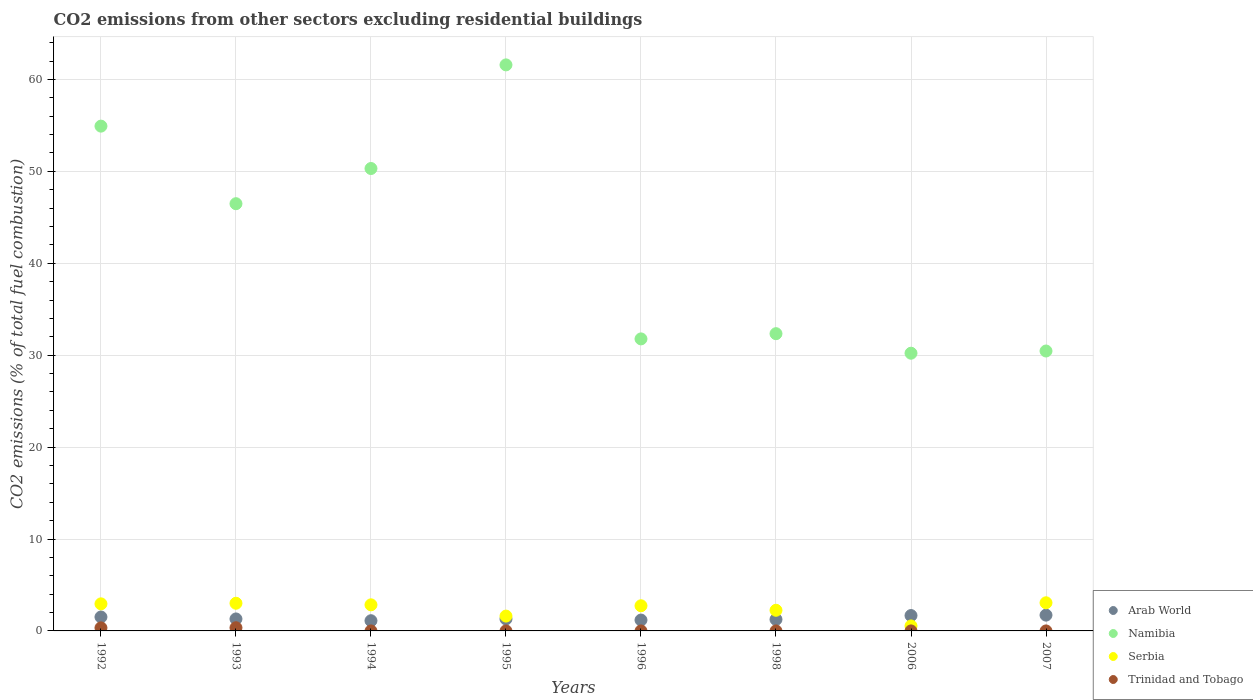How many different coloured dotlines are there?
Provide a short and direct response. 4. What is the total CO2 emitted in Trinidad and Tobago in 2007?
Keep it short and to the point. 4.75396951487204e-17. Across all years, what is the maximum total CO2 emitted in Trinidad and Tobago?
Your response must be concise. 0.35. Across all years, what is the minimum total CO2 emitted in Namibia?
Offer a very short reply. 30.21. What is the total total CO2 emitted in Trinidad and Tobago in the graph?
Your answer should be compact. 0.68. What is the difference between the total CO2 emitted in Serbia in 1995 and that in 2007?
Offer a very short reply. -1.45. What is the difference between the total CO2 emitted in Trinidad and Tobago in 1994 and the total CO2 emitted in Arab World in 1996?
Provide a short and direct response. -1.18. What is the average total CO2 emitted in Namibia per year?
Your response must be concise. 42.26. In the year 2006, what is the difference between the total CO2 emitted in Trinidad and Tobago and total CO2 emitted in Namibia?
Your answer should be compact. -30.21. In how many years, is the total CO2 emitted in Namibia greater than 48?
Your response must be concise. 3. What is the ratio of the total CO2 emitted in Namibia in 1992 to that in 1998?
Make the answer very short. 1.7. What is the difference between the highest and the second highest total CO2 emitted in Serbia?
Your answer should be very brief. 0.05. What is the difference between the highest and the lowest total CO2 emitted in Namibia?
Offer a very short reply. 31.37. In how many years, is the total CO2 emitted in Serbia greater than the average total CO2 emitted in Serbia taken over all years?
Keep it short and to the point. 5. Is the sum of the total CO2 emitted in Arab World in 1992 and 2007 greater than the maximum total CO2 emitted in Trinidad and Tobago across all years?
Your answer should be compact. Yes. Does the total CO2 emitted in Trinidad and Tobago monotonically increase over the years?
Provide a succinct answer. No. Is the total CO2 emitted in Trinidad and Tobago strictly greater than the total CO2 emitted in Arab World over the years?
Ensure brevity in your answer.  No. Is the total CO2 emitted in Arab World strictly less than the total CO2 emitted in Trinidad and Tobago over the years?
Provide a short and direct response. No. What is the difference between two consecutive major ticks on the Y-axis?
Your response must be concise. 10. Are the values on the major ticks of Y-axis written in scientific E-notation?
Your answer should be very brief. No. Does the graph contain any zero values?
Provide a short and direct response. Yes. How many legend labels are there?
Your answer should be compact. 4. How are the legend labels stacked?
Offer a terse response. Vertical. What is the title of the graph?
Provide a succinct answer. CO2 emissions from other sectors excluding residential buildings. Does "Mongolia" appear as one of the legend labels in the graph?
Provide a succinct answer. No. What is the label or title of the Y-axis?
Make the answer very short. CO2 emissions (% of total fuel combustion). What is the CO2 emissions (% of total fuel combustion) of Arab World in 1992?
Your response must be concise. 1.52. What is the CO2 emissions (% of total fuel combustion) of Namibia in 1992?
Make the answer very short. 54.92. What is the CO2 emissions (% of total fuel combustion) of Serbia in 1992?
Your response must be concise. 2.94. What is the CO2 emissions (% of total fuel combustion) in Trinidad and Tobago in 1992?
Your response must be concise. 0.33. What is the CO2 emissions (% of total fuel combustion) of Arab World in 1993?
Provide a succinct answer. 1.3. What is the CO2 emissions (% of total fuel combustion) of Namibia in 1993?
Ensure brevity in your answer.  46.48. What is the CO2 emissions (% of total fuel combustion) of Serbia in 1993?
Your answer should be compact. 3.01. What is the CO2 emissions (% of total fuel combustion) in Trinidad and Tobago in 1993?
Your answer should be compact. 0.35. What is the CO2 emissions (% of total fuel combustion) in Arab World in 1994?
Your answer should be compact. 1.11. What is the CO2 emissions (% of total fuel combustion) in Namibia in 1994?
Provide a succinct answer. 50.31. What is the CO2 emissions (% of total fuel combustion) of Serbia in 1994?
Your answer should be very brief. 2.84. What is the CO2 emissions (% of total fuel combustion) in Trinidad and Tobago in 1994?
Keep it short and to the point. 0. What is the CO2 emissions (% of total fuel combustion) in Arab World in 1995?
Make the answer very short. 1.3. What is the CO2 emissions (% of total fuel combustion) in Namibia in 1995?
Ensure brevity in your answer.  61.58. What is the CO2 emissions (% of total fuel combustion) of Serbia in 1995?
Offer a very short reply. 1.61. What is the CO2 emissions (% of total fuel combustion) in Arab World in 1996?
Provide a succinct answer. 1.18. What is the CO2 emissions (% of total fuel combustion) of Namibia in 1996?
Give a very brief answer. 31.77. What is the CO2 emissions (% of total fuel combustion) in Serbia in 1996?
Give a very brief answer. 2.74. What is the CO2 emissions (% of total fuel combustion) in Trinidad and Tobago in 1996?
Offer a terse response. 0. What is the CO2 emissions (% of total fuel combustion) in Arab World in 1998?
Keep it short and to the point. 1.25. What is the CO2 emissions (% of total fuel combustion) in Namibia in 1998?
Keep it short and to the point. 32.34. What is the CO2 emissions (% of total fuel combustion) in Serbia in 1998?
Your response must be concise. 2.25. What is the CO2 emissions (% of total fuel combustion) in Arab World in 2006?
Make the answer very short. 1.67. What is the CO2 emissions (% of total fuel combustion) in Namibia in 2006?
Ensure brevity in your answer.  30.21. What is the CO2 emissions (% of total fuel combustion) of Serbia in 2006?
Give a very brief answer. 0.54. What is the CO2 emissions (% of total fuel combustion) of Trinidad and Tobago in 2006?
Your answer should be very brief. 5.05750284541343e-17. What is the CO2 emissions (% of total fuel combustion) of Arab World in 2007?
Give a very brief answer. 1.72. What is the CO2 emissions (% of total fuel combustion) in Namibia in 2007?
Ensure brevity in your answer.  30.45. What is the CO2 emissions (% of total fuel combustion) of Serbia in 2007?
Make the answer very short. 3.06. What is the CO2 emissions (% of total fuel combustion) in Trinidad and Tobago in 2007?
Offer a very short reply. 4.75396951487204e-17. Across all years, what is the maximum CO2 emissions (% of total fuel combustion) of Arab World?
Offer a very short reply. 1.72. Across all years, what is the maximum CO2 emissions (% of total fuel combustion) of Namibia?
Offer a terse response. 61.58. Across all years, what is the maximum CO2 emissions (% of total fuel combustion) in Serbia?
Provide a short and direct response. 3.06. Across all years, what is the maximum CO2 emissions (% of total fuel combustion) in Trinidad and Tobago?
Your answer should be compact. 0.35. Across all years, what is the minimum CO2 emissions (% of total fuel combustion) in Arab World?
Make the answer very short. 1.11. Across all years, what is the minimum CO2 emissions (% of total fuel combustion) of Namibia?
Keep it short and to the point. 30.21. Across all years, what is the minimum CO2 emissions (% of total fuel combustion) in Serbia?
Ensure brevity in your answer.  0.54. What is the total CO2 emissions (% of total fuel combustion) in Arab World in the graph?
Your answer should be very brief. 11.05. What is the total CO2 emissions (% of total fuel combustion) in Namibia in the graph?
Your answer should be compact. 338.06. What is the total CO2 emissions (% of total fuel combustion) of Serbia in the graph?
Offer a terse response. 18.99. What is the total CO2 emissions (% of total fuel combustion) in Trinidad and Tobago in the graph?
Offer a very short reply. 0.68. What is the difference between the CO2 emissions (% of total fuel combustion) of Arab World in 1992 and that in 1993?
Give a very brief answer. 0.21. What is the difference between the CO2 emissions (% of total fuel combustion) of Namibia in 1992 and that in 1993?
Offer a very short reply. 8.44. What is the difference between the CO2 emissions (% of total fuel combustion) of Serbia in 1992 and that in 1993?
Offer a terse response. -0.07. What is the difference between the CO2 emissions (% of total fuel combustion) of Trinidad and Tobago in 1992 and that in 1993?
Your answer should be compact. -0.01. What is the difference between the CO2 emissions (% of total fuel combustion) of Arab World in 1992 and that in 1994?
Offer a very short reply. 0.41. What is the difference between the CO2 emissions (% of total fuel combustion) in Namibia in 1992 and that in 1994?
Provide a short and direct response. 4.61. What is the difference between the CO2 emissions (% of total fuel combustion) in Serbia in 1992 and that in 1994?
Your answer should be compact. 0.11. What is the difference between the CO2 emissions (% of total fuel combustion) of Arab World in 1992 and that in 1995?
Ensure brevity in your answer.  0.22. What is the difference between the CO2 emissions (% of total fuel combustion) in Namibia in 1992 and that in 1995?
Provide a short and direct response. -6.66. What is the difference between the CO2 emissions (% of total fuel combustion) of Serbia in 1992 and that in 1995?
Offer a terse response. 1.33. What is the difference between the CO2 emissions (% of total fuel combustion) in Arab World in 1992 and that in 1996?
Your response must be concise. 0.33. What is the difference between the CO2 emissions (% of total fuel combustion) of Namibia in 1992 and that in 1996?
Keep it short and to the point. 23.15. What is the difference between the CO2 emissions (% of total fuel combustion) in Serbia in 1992 and that in 1996?
Make the answer very short. 0.21. What is the difference between the CO2 emissions (% of total fuel combustion) in Arab World in 1992 and that in 1998?
Give a very brief answer. 0.27. What is the difference between the CO2 emissions (% of total fuel combustion) in Namibia in 1992 and that in 1998?
Provide a short and direct response. 22.58. What is the difference between the CO2 emissions (% of total fuel combustion) in Serbia in 1992 and that in 1998?
Offer a terse response. 0.7. What is the difference between the CO2 emissions (% of total fuel combustion) in Arab World in 1992 and that in 2006?
Your response must be concise. -0.16. What is the difference between the CO2 emissions (% of total fuel combustion) in Namibia in 1992 and that in 2006?
Your response must be concise. 24.71. What is the difference between the CO2 emissions (% of total fuel combustion) in Serbia in 1992 and that in 2006?
Your answer should be compact. 2.4. What is the difference between the CO2 emissions (% of total fuel combustion) of Trinidad and Tobago in 1992 and that in 2006?
Ensure brevity in your answer.  0.33. What is the difference between the CO2 emissions (% of total fuel combustion) in Arab World in 1992 and that in 2007?
Give a very brief answer. -0.2. What is the difference between the CO2 emissions (% of total fuel combustion) in Namibia in 1992 and that in 2007?
Your answer should be very brief. 24.47. What is the difference between the CO2 emissions (% of total fuel combustion) in Serbia in 1992 and that in 2007?
Provide a succinct answer. -0.12. What is the difference between the CO2 emissions (% of total fuel combustion) in Trinidad and Tobago in 1992 and that in 2007?
Keep it short and to the point. 0.33. What is the difference between the CO2 emissions (% of total fuel combustion) of Arab World in 1993 and that in 1994?
Ensure brevity in your answer.  0.19. What is the difference between the CO2 emissions (% of total fuel combustion) of Namibia in 1993 and that in 1994?
Keep it short and to the point. -3.83. What is the difference between the CO2 emissions (% of total fuel combustion) of Serbia in 1993 and that in 1994?
Give a very brief answer. 0.17. What is the difference between the CO2 emissions (% of total fuel combustion) of Arab World in 1993 and that in 1995?
Your answer should be very brief. 0. What is the difference between the CO2 emissions (% of total fuel combustion) of Namibia in 1993 and that in 1995?
Keep it short and to the point. -15.1. What is the difference between the CO2 emissions (% of total fuel combustion) in Serbia in 1993 and that in 1995?
Keep it short and to the point. 1.4. What is the difference between the CO2 emissions (% of total fuel combustion) of Arab World in 1993 and that in 1996?
Give a very brief answer. 0.12. What is the difference between the CO2 emissions (% of total fuel combustion) in Namibia in 1993 and that in 1996?
Your response must be concise. 14.71. What is the difference between the CO2 emissions (% of total fuel combustion) of Serbia in 1993 and that in 1996?
Ensure brevity in your answer.  0.27. What is the difference between the CO2 emissions (% of total fuel combustion) of Arab World in 1993 and that in 1998?
Provide a short and direct response. 0.06. What is the difference between the CO2 emissions (% of total fuel combustion) of Namibia in 1993 and that in 1998?
Ensure brevity in your answer.  14.14. What is the difference between the CO2 emissions (% of total fuel combustion) in Serbia in 1993 and that in 1998?
Your answer should be compact. 0.76. What is the difference between the CO2 emissions (% of total fuel combustion) of Arab World in 1993 and that in 2006?
Your response must be concise. -0.37. What is the difference between the CO2 emissions (% of total fuel combustion) of Namibia in 1993 and that in 2006?
Provide a succinct answer. 16.27. What is the difference between the CO2 emissions (% of total fuel combustion) in Serbia in 1993 and that in 2006?
Offer a very short reply. 2.47. What is the difference between the CO2 emissions (% of total fuel combustion) in Trinidad and Tobago in 1993 and that in 2006?
Give a very brief answer. 0.35. What is the difference between the CO2 emissions (% of total fuel combustion) in Arab World in 1993 and that in 2007?
Keep it short and to the point. -0.42. What is the difference between the CO2 emissions (% of total fuel combustion) in Namibia in 1993 and that in 2007?
Offer a terse response. 16.03. What is the difference between the CO2 emissions (% of total fuel combustion) in Serbia in 1993 and that in 2007?
Provide a short and direct response. -0.05. What is the difference between the CO2 emissions (% of total fuel combustion) of Trinidad and Tobago in 1993 and that in 2007?
Ensure brevity in your answer.  0.35. What is the difference between the CO2 emissions (% of total fuel combustion) in Arab World in 1994 and that in 1995?
Offer a terse response. -0.19. What is the difference between the CO2 emissions (% of total fuel combustion) of Namibia in 1994 and that in 1995?
Your response must be concise. -11.28. What is the difference between the CO2 emissions (% of total fuel combustion) in Serbia in 1994 and that in 1995?
Your answer should be compact. 1.22. What is the difference between the CO2 emissions (% of total fuel combustion) in Arab World in 1994 and that in 1996?
Keep it short and to the point. -0.07. What is the difference between the CO2 emissions (% of total fuel combustion) of Namibia in 1994 and that in 1996?
Offer a terse response. 18.54. What is the difference between the CO2 emissions (% of total fuel combustion) of Serbia in 1994 and that in 1996?
Ensure brevity in your answer.  0.1. What is the difference between the CO2 emissions (% of total fuel combustion) in Arab World in 1994 and that in 1998?
Ensure brevity in your answer.  -0.14. What is the difference between the CO2 emissions (% of total fuel combustion) of Namibia in 1994 and that in 1998?
Give a very brief answer. 17.97. What is the difference between the CO2 emissions (% of total fuel combustion) of Serbia in 1994 and that in 1998?
Give a very brief answer. 0.59. What is the difference between the CO2 emissions (% of total fuel combustion) of Arab World in 1994 and that in 2006?
Provide a short and direct response. -0.56. What is the difference between the CO2 emissions (% of total fuel combustion) in Namibia in 1994 and that in 2006?
Offer a terse response. 20.09. What is the difference between the CO2 emissions (% of total fuel combustion) in Serbia in 1994 and that in 2006?
Provide a short and direct response. 2.3. What is the difference between the CO2 emissions (% of total fuel combustion) of Arab World in 1994 and that in 2007?
Your answer should be very brief. -0.61. What is the difference between the CO2 emissions (% of total fuel combustion) in Namibia in 1994 and that in 2007?
Offer a very short reply. 19.85. What is the difference between the CO2 emissions (% of total fuel combustion) of Serbia in 1994 and that in 2007?
Your answer should be compact. -0.22. What is the difference between the CO2 emissions (% of total fuel combustion) in Arab World in 1995 and that in 1996?
Give a very brief answer. 0.12. What is the difference between the CO2 emissions (% of total fuel combustion) in Namibia in 1995 and that in 1996?
Give a very brief answer. 29.81. What is the difference between the CO2 emissions (% of total fuel combustion) of Serbia in 1995 and that in 1996?
Provide a short and direct response. -1.12. What is the difference between the CO2 emissions (% of total fuel combustion) in Arab World in 1995 and that in 1998?
Give a very brief answer. 0.05. What is the difference between the CO2 emissions (% of total fuel combustion) in Namibia in 1995 and that in 1998?
Your answer should be very brief. 29.24. What is the difference between the CO2 emissions (% of total fuel combustion) of Serbia in 1995 and that in 1998?
Your answer should be very brief. -0.63. What is the difference between the CO2 emissions (% of total fuel combustion) in Arab World in 1995 and that in 2006?
Offer a very short reply. -0.37. What is the difference between the CO2 emissions (% of total fuel combustion) of Namibia in 1995 and that in 2006?
Your response must be concise. 31.37. What is the difference between the CO2 emissions (% of total fuel combustion) of Serbia in 1995 and that in 2006?
Give a very brief answer. 1.07. What is the difference between the CO2 emissions (% of total fuel combustion) in Arab World in 1995 and that in 2007?
Provide a short and direct response. -0.42. What is the difference between the CO2 emissions (% of total fuel combustion) of Namibia in 1995 and that in 2007?
Offer a terse response. 31.13. What is the difference between the CO2 emissions (% of total fuel combustion) of Serbia in 1995 and that in 2007?
Make the answer very short. -1.45. What is the difference between the CO2 emissions (% of total fuel combustion) of Arab World in 1996 and that in 1998?
Offer a very short reply. -0.07. What is the difference between the CO2 emissions (% of total fuel combustion) of Namibia in 1996 and that in 1998?
Offer a very short reply. -0.57. What is the difference between the CO2 emissions (% of total fuel combustion) of Serbia in 1996 and that in 1998?
Offer a very short reply. 0.49. What is the difference between the CO2 emissions (% of total fuel combustion) in Arab World in 1996 and that in 2006?
Give a very brief answer. -0.49. What is the difference between the CO2 emissions (% of total fuel combustion) of Namibia in 1996 and that in 2006?
Offer a terse response. 1.56. What is the difference between the CO2 emissions (% of total fuel combustion) of Serbia in 1996 and that in 2006?
Offer a very short reply. 2.19. What is the difference between the CO2 emissions (% of total fuel combustion) in Arab World in 1996 and that in 2007?
Offer a very short reply. -0.54. What is the difference between the CO2 emissions (% of total fuel combustion) of Namibia in 1996 and that in 2007?
Your answer should be compact. 1.32. What is the difference between the CO2 emissions (% of total fuel combustion) in Serbia in 1996 and that in 2007?
Ensure brevity in your answer.  -0.33. What is the difference between the CO2 emissions (% of total fuel combustion) of Arab World in 1998 and that in 2006?
Keep it short and to the point. -0.42. What is the difference between the CO2 emissions (% of total fuel combustion) of Namibia in 1998 and that in 2006?
Offer a very short reply. 2.13. What is the difference between the CO2 emissions (% of total fuel combustion) in Serbia in 1998 and that in 2006?
Ensure brevity in your answer.  1.7. What is the difference between the CO2 emissions (% of total fuel combustion) in Arab World in 1998 and that in 2007?
Provide a short and direct response. -0.47. What is the difference between the CO2 emissions (% of total fuel combustion) of Namibia in 1998 and that in 2007?
Give a very brief answer. 1.89. What is the difference between the CO2 emissions (% of total fuel combustion) in Serbia in 1998 and that in 2007?
Offer a terse response. -0.82. What is the difference between the CO2 emissions (% of total fuel combustion) of Arab World in 2006 and that in 2007?
Keep it short and to the point. -0.05. What is the difference between the CO2 emissions (% of total fuel combustion) in Namibia in 2006 and that in 2007?
Keep it short and to the point. -0.24. What is the difference between the CO2 emissions (% of total fuel combustion) of Serbia in 2006 and that in 2007?
Your answer should be compact. -2.52. What is the difference between the CO2 emissions (% of total fuel combustion) in Trinidad and Tobago in 2006 and that in 2007?
Make the answer very short. 0. What is the difference between the CO2 emissions (% of total fuel combustion) of Arab World in 1992 and the CO2 emissions (% of total fuel combustion) of Namibia in 1993?
Ensure brevity in your answer.  -44.96. What is the difference between the CO2 emissions (% of total fuel combustion) of Arab World in 1992 and the CO2 emissions (% of total fuel combustion) of Serbia in 1993?
Provide a short and direct response. -1.5. What is the difference between the CO2 emissions (% of total fuel combustion) of Arab World in 1992 and the CO2 emissions (% of total fuel combustion) of Trinidad and Tobago in 1993?
Your answer should be very brief. 1.17. What is the difference between the CO2 emissions (% of total fuel combustion) in Namibia in 1992 and the CO2 emissions (% of total fuel combustion) in Serbia in 1993?
Keep it short and to the point. 51.91. What is the difference between the CO2 emissions (% of total fuel combustion) of Namibia in 1992 and the CO2 emissions (% of total fuel combustion) of Trinidad and Tobago in 1993?
Provide a short and direct response. 54.57. What is the difference between the CO2 emissions (% of total fuel combustion) of Serbia in 1992 and the CO2 emissions (% of total fuel combustion) of Trinidad and Tobago in 1993?
Give a very brief answer. 2.6. What is the difference between the CO2 emissions (% of total fuel combustion) in Arab World in 1992 and the CO2 emissions (% of total fuel combustion) in Namibia in 1994?
Your answer should be very brief. -48.79. What is the difference between the CO2 emissions (% of total fuel combustion) in Arab World in 1992 and the CO2 emissions (% of total fuel combustion) in Serbia in 1994?
Provide a succinct answer. -1.32. What is the difference between the CO2 emissions (% of total fuel combustion) of Namibia in 1992 and the CO2 emissions (% of total fuel combustion) of Serbia in 1994?
Make the answer very short. 52.08. What is the difference between the CO2 emissions (% of total fuel combustion) of Arab World in 1992 and the CO2 emissions (% of total fuel combustion) of Namibia in 1995?
Your response must be concise. -60.07. What is the difference between the CO2 emissions (% of total fuel combustion) of Arab World in 1992 and the CO2 emissions (% of total fuel combustion) of Serbia in 1995?
Keep it short and to the point. -0.1. What is the difference between the CO2 emissions (% of total fuel combustion) of Namibia in 1992 and the CO2 emissions (% of total fuel combustion) of Serbia in 1995?
Your answer should be compact. 53.3. What is the difference between the CO2 emissions (% of total fuel combustion) of Arab World in 1992 and the CO2 emissions (% of total fuel combustion) of Namibia in 1996?
Make the answer very short. -30.26. What is the difference between the CO2 emissions (% of total fuel combustion) of Arab World in 1992 and the CO2 emissions (% of total fuel combustion) of Serbia in 1996?
Offer a very short reply. -1.22. What is the difference between the CO2 emissions (% of total fuel combustion) of Namibia in 1992 and the CO2 emissions (% of total fuel combustion) of Serbia in 1996?
Give a very brief answer. 52.18. What is the difference between the CO2 emissions (% of total fuel combustion) of Arab World in 1992 and the CO2 emissions (% of total fuel combustion) of Namibia in 1998?
Your answer should be compact. -30.82. What is the difference between the CO2 emissions (% of total fuel combustion) in Arab World in 1992 and the CO2 emissions (% of total fuel combustion) in Serbia in 1998?
Make the answer very short. -0.73. What is the difference between the CO2 emissions (% of total fuel combustion) in Namibia in 1992 and the CO2 emissions (% of total fuel combustion) in Serbia in 1998?
Keep it short and to the point. 52.67. What is the difference between the CO2 emissions (% of total fuel combustion) in Arab World in 1992 and the CO2 emissions (% of total fuel combustion) in Namibia in 2006?
Provide a short and direct response. -28.7. What is the difference between the CO2 emissions (% of total fuel combustion) in Arab World in 1992 and the CO2 emissions (% of total fuel combustion) in Serbia in 2006?
Provide a short and direct response. 0.97. What is the difference between the CO2 emissions (% of total fuel combustion) in Arab World in 1992 and the CO2 emissions (% of total fuel combustion) in Trinidad and Tobago in 2006?
Ensure brevity in your answer.  1.52. What is the difference between the CO2 emissions (% of total fuel combustion) of Namibia in 1992 and the CO2 emissions (% of total fuel combustion) of Serbia in 2006?
Keep it short and to the point. 54.38. What is the difference between the CO2 emissions (% of total fuel combustion) of Namibia in 1992 and the CO2 emissions (% of total fuel combustion) of Trinidad and Tobago in 2006?
Offer a very short reply. 54.92. What is the difference between the CO2 emissions (% of total fuel combustion) in Serbia in 1992 and the CO2 emissions (% of total fuel combustion) in Trinidad and Tobago in 2006?
Provide a short and direct response. 2.94. What is the difference between the CO2 emissions (% of total fuel combustion) of Arab World in 1992 and the CO2 emissions (% of total fuel combustion) of Namibia in 2007?
Ensure brevity in your answer.  -28.94. What is the difference between the CO2 emissions (% of total fuel combustion) in Arab World in 1992 and the CO2 emissions (% of total fuel combustion) in Serbia in 2007?
Make the answer very short. -1.55. What is the difference between the CO2 emissions (% of total fuel combustion) in Arab World in 1992 and the CO2 emissions (% of total fuel combustion) in Trinidad and Tobago in 2007?
Make the answer very short. 1.52. What is the difference between the CO2 emissions (% of total fuel combustion) in Namibia in 1992 and the CO2 emissions (% of total fuel combustion) in Serbia in 2007?
Your response must be concise. 51.86. What is the difference between the CO2 emissions (% of total fuel combustion) in Namibia in 1992 and the CO2 emissions (% of total fuel combustion) in Trinidad and Tobago in 2007?
Provide a succinct answer. 54.92. What is the difference between the CO2 emissions (% of total fuel combustion) in Serbia in 1992 and the CO2 emissions (% of total fuel combustion) in Trinidad and Tobago in 2007?
Give a very brief answer. 2.94. What is the difference between the CO2 emissions (% of total fuel combustion) of Arab World in 1993 and the CO2 emissions (% of total fuel combustion) of Namibia in 1994?
Keep it short and to the point. -49. What is the difference between the CO2 emissions (% of total fuel combustion) of Arab World in 1993 and the CO2 emissions (% of total fuel combustion) of Serbia in 1994?
Provide a short and direct response. -1.53. What is the difference between the CO2 emissions (% of total fuel combustion) of Namibia in 1993 and the CO2 emissions (% of total fuel combustion) of Serbia in 1994?
Keep it short and to the point. 43.64. What is the difference between the CO2 emissions (% of total fuel combustion) of Arab World in 1993 and the CO2 emissions (% of total fuel combustion) of Namibia in 1995?
Your answer should be compact. -60.28. What is the difference between the CO2 emissions (% of total fuel combustion) in Arab World in 1993 and the CO2 emissions (% of total fuel combustion) in Serbia in 1995?
Ensure brevity in your answer.  -0.31. What is the difference between the CO2 emissions (% of total fuel combustion) in Namibia in 1993 and the CO2 emissions (% of total fuel combustion) in Serbia in 1995?
Your answer should be compact. 44.86. What is the difference between the CO2 emissions (% of total fuel combustion) of Arab World in 1993 and the CO2 emissions (% of total fuel combustion) of Namibia in 1996?
Your answer should be compact. -30.47. What is the difference between the CO2 emissions (% of total fuel combustion) in Arab World in 1993 and the CO2 emissions (% of total fuel combustion) in Serbia in 1996?
Give a very brief answer. -1.43. What is the difference between the CO2 emissions (% of total fuel combustion) of Namibia in 1993 and the CO2 emissions (% of total fuel combustion) of Serbia in 1996?
Make the answer very short. 43.74. What is the difference between the CO2 emissions (% of total fuel combustion) of Arab World in 1993 and the CO2 emissions (% of total fuel combustion) of Namibia in 1998?
Offer a terse response. -31.03. What is the difference between the CO2 emissions (% of total fuel combustion) in Arab World in 1993 and the CO2 emissions (% of total fuel combustion) in Serbia in 1998?
Keep it short and to the point. -0.94. What is the difference between the CO2 emissions (% of total fuel combustion) of Namibia in 1993 and the CO2 emissions (% of total fuel combustion) of Serbia in 1998?
Ensure brevity in your answer.  44.23. What is the difference between the CO2 emissions (% of total fuel combustion) of Arab World in 1993 and the CO2 emissions (% of total fuel combustion) of Namibia in 2006?
Provide a succinct answer. -28.91. What is the difference between the CO2 emissions (% of total fuel combustion) of Arab World in 1993 and the CO2 emissions (% of total fuel combustion) of Serbia in 2006?
Keep it short and to the point. 0.76. What is the difference between the CO2 emissions (% of total fuel combustion) in Arab World in 1993 and the CO2 emissions (% of total fuel combustion) in Trinidad and Tobago in 2006?
Keep it short and to the point. 1.3. What is the difference between the CO2 emissions (% of total fuel combustion) of Namibia in 1993 and the CO2 emissions (% of total fuel combustion) of Serbia in 2006?
Ensure brevity in your answer.  45.94. What is the difference between the CO2 emissions (% of total fuel combustion) of Namibia in 1993 and the CO2 emissions (% of total fuel combustion) of Trinidad and Tobago in 2006?
Give a very brief answer. 46.48. What is the difference between the CO2 emissions (% of total fuel combustion) of Serbia in 1993 and the CO2 emissions (% of total fuel combustion) of Trinidad and Tobago in 2006?
Your answer should be very brief. 3.01. What is the difference between the CO2 emissions (% of total fuel combustion) of Arab World in 1993 and the CO2 emissions (% of total fuel combustion) of Namibia in 2007?
Provide a succinct answer. -29.15. What is the difference between the CO2 emissions (% of total fuel combustion) in Arab World in 1993 and the CO2 emissions (% of total fuel combustion) in Serbia in 2007?
Your response must be concise. -1.76. What is the difference between the CO2 emissions (% of total fuel combustion) of Arab World in 1993 and the CO2 emissions (% of total fuel combustion) of Trinidad and Tobago in 2007?
Keep it short and to the point. 1.3. What is the difference between the CO2 emissions (% of total fuel combustion) in Namibia in 1993 and the CO2 emissions (% of total fuel combustion) in Serbia in 2007?
Provide a short and direct response. 43.42. What is the difference between the CO2 emissions (% of total fuel combustion) of Namibia in 1993 and the CO2 emissions (% of total fuel combustion) of Trinidad and Tobago in 2007?
Make the answer very short. 46.48. What is the difference between the CO2 emissions (% of total fuel combustion) of Serbia in 1993 and the CO2 emissions (% of total fuel combustion) of Trinidad and Tobago in 2007?
Your answer should be compact. 3.01. What is the difference between the CO2 emissions (% of total fuel combustion) of Arab World in 1994 and the CO2 emissions (% of total fuel combustion) of Namibia in 1995?
Give a very brief answer. -60.47. What is the difference between the CO2 emissions (% of total fuel combustion) of Arab World in 1994 and the CO2 emissions (% of total fuel combustion) of Serbia in 1995?
Make the answer very short. -0.5. What is the difference between the CO2 emissions (% of total fuel combustion) of Namibia in 1994 and the CO2 emissions (% of total fuel combustion) of Serbia in 1995?
Make the answer very short. 48.69. What is the difference between the CO2 emissions (% of total fuel combustion) in Arab World in 1994 and the CO2 emissions (% of total fuel combustion) in Namibia in 1996?
Ensure brevity in your answer.  -30.66. What is the difference between the CO2 emissions (% of total fuel combustion) of Arab World in 1994 and the CO2 emissions (% of total fuel combustion) of Serbia in 1996?
Give a very brief answer. -1.63. What is the difference between the CO2 emissions (% of total fuel combustion) of Namibia in 1994 and the CO2 emissions (% of total fuel combustion) of Serbia in 1996?
Your answer should be very brief. 47.57. What is the difference between the CO2 emissions (% of total fuel combustion) of Arab World in 1994 and the CO2 emissions (% of total fuel combustion) of Namibia in 1998?
Offer a terse response. -31.23. What is the difference between the CO2 emissions (% of total fuel combustion) of Arab World in 1994 and the CO2 emissions (% of total fuel combustion) of Serbia in 1998?
Provide a short and direct response. -1.14. What is the difference between the CO2 emissions (% of total fuel combustion) in Namibia in 1994 and the CO2 emissions (% of total fuel combustion) in Serbia in 1998?
Offer a very short reply. 48.06. What is the difference between the CO2 emissions (% of total fuel combustion) in Arab World in 1994 and the CO2 emissions (% of total fuel combustion) in Namibia in 2006?
Provide a short and direct response. -29.1. What is the difference between the CO2 emissions (% of total fuel combustion) of Arab World in 1994 and the CO2 emissions (% of total fuel combustion) of Serbia in 2006?
Offer a terse response. 0.57. What is the difference between the CO2 emissions (% of total fuel combustion) of Arab World in 1994 and the CO2 emissions (% of total fuel combustion) of Trinidad and Tobago in 2006?
Your answer should be very brief. 1.11. What is the difference between the CO2 emissions (% of total fuel combustion) in Namibia in 1994 and the CO2 emissions (% of total fuel combustion) in Serbia in 2006?
Give a very brief answer. 49.76. What is the difference between the CO2 emissions (% of total fuel combustion) in Namibia in 1994 and the CO2 emissions (% of total fuel combustion) in Trinidad and Tobago in 2006?
Your answer should be very brief. 50.31. What is the difference between the CO2 emissions (% of total fuel combustion) of Serbia in 1994 and the CO2 emissions (% of total fuel combustion) of Trinidad and Tobago in 2006?
Your answer should be compact. 2.84. What is the difference between the CO2 emissions (% of total fuel combustion) in Arab World in 1994 and the CO2 emissions (% of total fuel combustion) in Namibia in 2007?
Make the answer very short. -29.34. What is the difference between the CO2 emissions (% of total fuel combustion) in Arab World in 1994 and the CO2 emissions (% of total fuel combustion) in Serbia in 2007?
Keep it short and to the point. -1.95. What is the difference between the CO2 emissions (% of total fuel combustion) in Arab World in 1994 and the CO2 emissions (% of total fuel combustion) in Trinidad and Tobago in 2007?
Make the answer very short. 1.11. What is the difference between the CO2 emissions (% of total fuel combustion) of Namibia in 1994 and the CO2 emissions (% of total fuel combustion) of Serbia in 2007?
Your response must be concise. 47.25. What is the difference between the CO2 emissions (% of total fuel combustion) in Namibia in 1994 and the CO2 emissions (% of total fuel combustion) in Trinidad and Tobago in 2007?
Ensure brevity in your answer.  50.31. What is the difference between the CO2 emissions (% of total fuel combustion) of Serbia in 1994 and the CO2 emissions (% of total fuel combustion) of Trinidad and Tobago in 2007?
Ensure brevity in your answer.  2.84. What is the difference between the CO2 emissions (% of total fuel combustion) in Arab World in 1995 and the CO2 emissions (% of total fuel combustion) in Namibia in 1996?
Offer a very short reply. -30.47. What is the difference between the CO2 emissions (% of total fuel combustion) of Arab World in 1995 and the CO2 emissions (% of total fuel combustion) of Serbia in 1996?
Give a very brief answer. -1.44. What is the difference between the CO2 emissions (% of total fuel combustion) in Namibia in 1995 and the CO2 emissions (% of total fuel combustion) in Serbia in 1996?
Give a very brief answer. 58.85. What is the difference between the CO2 emissions (% of total fuel combustion) in Arab World in 1995 and the CO2 emissions (% of total fuel combustion) in Namibia in 1998?
Your response must be concise. -31.04. What is the difference between the CO2 emissions (% of total fuel combustion) of Arab World in 1995 and the CO2 emissions (% of total fuel combustion) of Serbia in 1998?
Offer a terse response. -0.95. What is the difference between the CO2 emissions (% of total fuel combustion) in Namibia in 1995 and the CO2 emissions (% of total fuel combustion) in Serbia in 1998?
Your response must be concise. 59.34. What is the difference between the CO2 emissions (% of total fuel combustion) of Arab World in 1995 and the CO2 emissions (% of total fuel combustion) of Namibia in 2006?
Make the answer very short. -28.91. What is the difference between the CO2 emissions (% of total fuel combustion) of Arab World in 1995 and the CO2 emissions (% of total fuel combustion) of Serbia in 2006?
Make the answer very short. 0.76. What is the difference between the CO2 emissions (% of total fuel combustion) in Arab World in 1995 and the CO2 emissions (% of total fuel combustion) in Trinidad and Tobago in 2006?
Give a very brief answer. 1.3. What is the difference between the CO2 emissions (% of total fuel combustion) of Namibia in 1995 and the CO2 emissions (% of total fuel combustion) of Serbia in 2006?
Offer a terse response. 61.04. What is the difference between the CO2 emissions (% of total fuel combustion) of Namibia in 1995 and the CO2 emissions (% of total fuel combustion) of Trinidad and Tobago in 2006?
Your answer should be compact. 61.58. What is the difference between the CO2 emissions (% of total fuel combustion) in Serbia in 1995 and the CO2 emissions (% of total fuel combustion) in Trinidad and Tobago in 2006?
Make the answer very short. 1.61. What is the difference between the CO2 emissions (% of total fuel combustion) of Arab World in 1995 and the CO2 emissions (% of total fuel combustion) of Namibia in 2007?
Provide a short and direct response. -29.15. What is the difference between the CO2 emissions (% of total fuel combustion) in Arab World in 1995 and the CO2 emissions (% of total fuel combustion) in Serbia in 2007?
Offer a very short reply. -1.76. What is the difference between the CO2 emissions (% of total fuel combustion) of Arab World in 1995 and the CO2 emissions (% of total fuel combustion) of Trinidad and Tobago in 2007?
Your response must be concise. 1.3. What is the difference between the CO2 emissions (% of total fuel combustion) in Namibia in 1995 and the CO2 emissions (% of total fuel combustion) in Serbia in 2007?
Provide a succinct answer. 58.52. What is the difference between the CO2 emissions (% of total fuel combustion) of Namibia in 1995 and the CO2 emissions (% of total fuel combustion) of Trinidad and Tobago in 2007?
Provide a succinct answer. 61.58. What is the difference between the CO2 emissions (% of total fuel combustion) in Serbia in 1995 and the CO2 emissions (% of total fuel combustion) in Trinidad and Tobago in 2007?
Offer a terse response. 1.61. What is the difference between the CO2 emissions (% of total fuel combustion) in Arab World in 1996 and the CO2 emissions (% of total fuel combustion) in Namibia in 1998?
Ensure brevity in your answer.  -31.16. What is the difference between the CO2 emissions (% of total fuel combustion) in Arab World in 1996 and the CO2 emissions (% of total fuel combustion) in Serbia in 1998?
Provide a short and direct response. -1.06. What is the difference between the CO2 emissions (% of total fuel combustion) in Namibia in 1996 and the CO2 emissions (% of total fuel combustion) in Serbia in 1998?
Make the answer very short. 29.53. What is the difference between the CO2 emissions (% of total fuel combustion) of Arab World in 1996 and the CO2 emissions (% of total fuel combustion) of Namibia in 2006?
Provide a short and direct response. -29.03. What is the difference between the CO2 emissions (% of total fuel combustion) in Arab World in 1996 and the CO2 emissions (% of total fuel combustion) in Serbia in 2006?
Your response must be concise. 0.64. What is the difference between the CO2 emissions (% of total fuel combustion) in Arab World in 1996 and the CO2 emissions (% of total fuel combustion) in Trinidad and Tobago in 2006?
Keep it short and to the point. 1.18. What is the difference between the CO2 emissions (% of total fuel combustion) of Namibia in 1996 and the CO2 emissions (% of total fuel combustion) of Serbia in 2006?
Offer a very short reply. 31.23. What is the difference between the CO2 emissions (% of total fuel combustion) in Namibia in 1996 and the CO2 emissions (% of total fuel combustion) in Trinidad and Tobago in 2006?
Offer a very short reply. 31.77. What is the difference between the CO2 emissions (% of total fuel combustion) of Serbia in 1996 and the CO2 emissions (% of total fuel combustion) of Trinidad and Tobago in 2006?
Make the answer very short. 2.74. What is the difference between the CO2 emissions (% of total fuel combustion) of Arab World in 1996 and the CO2 emissions (% of total fuel combustion) of Namibia in 2007?
Keep it short and to the point. -29.27. What is the difference between the CO2 emissions (% of total fuel combustion) in Arab World in 1996 and the CO2 emissions (% of total fuel combustion) in Serbia in 2007?
Your answer should be compact. -1.88. What is the difference between the CO2 emissions (% of total fuel combustion) of Arab World in 1996 and the CO2 emissions (% of total fuel combustion) of Trinidad and Tobago in 2007?
Make the answer very short. 1.18. What is the difference between the CO2 emissions (% of total fuel combustion) in Namibia in 1996 and the CO2 emissions (% of total fuel combustion) in Serbia in 2007?
Give a very brief answer. 28.71. What is the difference between the CO2 emissions (% of total fuel combustion) in Namibia in 1996 and the CO2 emissions (% of total fuel combustion) in Trinidad and Tobago in 2007?
Ensure brevity in your answer.  31.77. What is the difference between the CO2 emissions (% of total fuel combustion) in Serbia in 1996 and the CO2 emissions (% of total fuel combustion) in Trinidad and Tobago in 2007?
Your answer should be compact. 2.74. What is the difference between the CO2 emissions (% of total fuel combustion) of Arab World in 1998 and the CO2 emissions (% of total fuel combustion) of Namibia in 2006?
Make the answer very short. -28.96. What is the difference between the CO2 emissions (% of total fuel combustion) in Arab World in 1998 and the CO2 emissions (% of total fuel combustion) in Serbia in 2006?
Offer a terse response. 0.71. What is the difference between the CO2 emissions (% of total fuel combustion) in Arab World in 1998 and the CO2 emissions (% of total fuel combustion) in Trinidad and Tobago in 2006?
Provide a short and direct response. 1.25. What is the difference between the CO2 emissions (% of total fuel combustion) of Namibia in 1998 and the CO2 emissions (% of total fuel combustion) of Serbia in 2006?
Keep it short and to the point. 31.8. What is the difference between the CO2 emissions (% of total fuel combustion) of Namibia in 1998 and the CO2 emissions (% of total fuel combustion) of Trinidad and Tobago in 2006?
Make the answer very short. 32.34. What is the difference between the CO2 emissions (% of total fuel combustion) of Serbia in 1998 and the CO2 emissions (% of total fuel combustion) of Trinidad and Tobago in 2006?
Provide a succinct answer. 2.25. What is the difference between the CO2 emissions (% of total fuel combustion) in Arab World in 1998 and the CO2 emissions (% of total fuel combustion) in Namibia in 2007?
Your response must be concise. -29.2. What is the difference between the CO2 emissions (% of total fuel combustion) of Arab World in 1998 and the CO2 emissions (% of total fuel combustion) of Serbia in 2007?
Keep it short and to the point. -1.81. What is the difference between the CO2 emissions (% of total fuel combustion) of Arab World in 1998 and the CO2 emissions (% of total fuel combustion) of Trinidad and Tobago in 2007?
Your response must be concise. 1.25. What is the difference between the CO2 emissions (% of total fuel combustion) in Namibia in 1998 and the CO2 emissions (% of total fuel combustion) in Serbia in 2007?
Keep it short and to the point. 29.28. What is the difference between the CO2 emissions (% of total fuel combustion) in Namibia in 1998 and the CO2 emissions (% of total fuel combustion) in Trinidad and Tobago in 2007?
Your answer should be very brief. 32.34. What is the difference between the CO2 emissions (% of total fuel combustion) of Serbia in 1998 and the CO2 emissions (% of total fuel combustion) of Trinidad and Tobago in 2007?
Provide a short and direct response. 2.25. What is the difference between the CO2 emissions (% of total fuel combustion) in Arab World in 2006 and the CO2 emissions (% of total fuel combustion) in Namibia in 2007?
Provide a succinct answer. -28.78. What is the difference between the CO2 emissions (% of total fuel combustion) in Arab World in 2006 and the CO2 emissions (% of total fuel combustion) in Serbia in 2007?
Make the answer very short. -1.39. What is the difference between the CO2 emissions (% of total fuel combustion) of Arab World in 2006 and the CO2 emissions (% of total fuel combustion) of Trinidad and Tobago in 2007?
Offer a terse response. 1.67. What is the difference between the CO2 emissions (% of total fuel combustion) in Namibia in 2006 and the CO2 emissions (% of total fuel combustion) in Serbia in 2007?
Your response must be concise. 27.15. What is the difference between the CO2 emissions (% of total fuel combustion) of Namibia in 2006 and the CO2 emissions (% of total fuel combustion) of Trinidad and Tobago in 2007?
Your answer should be compact. 30.21. What is the difference between the CO2 emissions (% of total fuel combustion) in Serbia in 2006 and the CO2 emissions (% of total fuel combustion) in Trinidad and Tobago in 2007?
Keep it short and to the point. 0.54. What is the average CO2 emissions (% of total fuel combustion) of Arab World per year?
Give a very brief answer. 1.38. What is the average CO2 emissions (% of total fuel combustion) in Namibia per year?
Give a very brief answer. 42.26. What is the average CO2 emissions (% of total fuel combustion) in Serbia per year?
Give a very brief answer. 2.37. What is the average CO2 emissions (% of total fuel combustion) in Trinidad and Tobago per year?
Your response must be concise. 0.09. In the year 1992, what is the difference between the CO2 emissions (% of total fuel combustion) of Arab World and CO2 emissions (% of total fuel combustion) of Namibia?
Provide a short and direct response. -53.4. In the year 1992, what is the difference between the CO2 emissions (% of total fuel combustion) in Arab World and CO2 emissions (% of total fuel combustion) in Serbia?
Keep it short and to the point. -1.43. In the year 1992, what is the difference between the CO2 emissions (% of total fuel combustion) in Arab World and CO2 emissions (% of total fuel combustion) in Trinidad and Tobago?
Your answer should be compact. 1.18. In the year 1992, what is the difference between the CO2 emissions (% of total fuel combustion) of Namibia and CO2 emissions (% of total fuel combustion) of Serbia?
Your answer should be very brief. 51.97. In the year 1992, what is the difference between the CO2 emissions (% of total fuel combustion) in Namibia and CO2 emissions (% of total fuel combustion) in Trinidad and Tobago?
Offer a very short reply. 54.58. In the year 1992, what is the difference between the CO2 emissions (% of total fuel combustion) of Serbia and CO2 emissions (% of total fuel combustion) of Trinidad and Tobago?
Offer a terse response. 2.61. In the year 1993, what is the difference between the CO2 emissions (% of total fuel combustion) of Arab World and CO2 emissions (% of total fuel combustion) of Namibia?
Your answer should be very brief. -45.17. In the year 1993, what is the difference between the CO2 emissions (% of total fuel combustion) in Arab World and CO2 emissions (% of total fuel combustion) in Serbia?
Your answer should be very brief. -1.71. In the year 1993, what is the difference between the CO2 emissions (% of total fuel combustion) of Arab World and CO2 emissions (% of total fuel combustion) of Trinidad and Tobago?
Your answer should be compact. 0.96. In the year 1993, what is the difference between the CO2 emissions (% of total fuel combustion) of Namibia and CO2 emissions (% of total fuel combustion) of Serbia?
Provide a short and direct response. 43.47. In the year 1993, what is the difference between the CO2 emissions (% of total fuel combustion) of Namibia and CO2 emissions (% of total fuel combustion) of Trinidad and Tobago?
Offer a terse response. 46.13. In the year 1993, what is the difference between the CO2 emissions (% of total fuel combustion) in Serbia and CO2 emissions (% of total fuel combustion) in Trinidad and Tobago?
Your answer should be compact. 2.66. In the year 1994, what is the difference between the CO2 emissions (% of total fuel combustion) of Arab World and CO2 emissions (% of total fuel combustion) of Namibia?
Your response must be concise. -49.2. In the year 1994, what is the difference between the CO2 emissions (% of total fuel combustion) of Arab World and CO2 emissions (% of total fuel combustion) of Serbia?
Keep it short and to the point. -1.73. In the year 1994, what is the difference between the CO2 emissions (% of total fuel combustion) in Namibia and CO2 emissions (% of total fuel combustion) in Serbia?
Provide a succinct answer. 47.47. In the year 1995, what is the difference between the CO2 emissions (% of total fuel combustion) of Arab World and CO2 emissions (% of total fuel combustion) of Namibia?
Offer a terse response. -60.28. In the year 1995, what is the difference between the CO2 emissions (% of total fuel combustion) of Arab World and CO2 emissions (% of total fuel combustion) of Serbia?
Offer a very short reply. -0.31. In the year 1995, what is the difference between the CO2 emissions (% of total fuel combustion) in Namibia and CO2 emissions (% of total fuel combustion) in Serbia?
Your answer should be compact. 59.97. In the year 1996, what is the difference between the CO2 emissions (% of total fuel combustion) in Arab World and CO2 emissions (% of total fuel combustion) in Namibia?
Your answer should be compact. -30.59. In the year 1996, what is the difference between the CO2 emissions (% of total fuel combustion) in Arab World and CO2 emissions (% of total fuel combustion) in Serbia?
Keep it short and to the point. -1.55. In the year 1996, what is the difference between the CO2 emissions (% of total fuel combustion) of Namibia and CO2 emissions (% of total fuel combustion) of Serbia?
Provide a succinct answer. 29.03. In the year 1998, what is the difference between the CO2 emissions (% of total fuel combustion) of Arab World and CO2 emissions (% of total fuel combustion) of Namibia?
Ensure brevity in your answer.  -31.09. In the year 1998, what is the difference between the CO2 emissions (% of total fuel combustion) of Arab World and CO2 emissions (% of total fuel combustion) of Serbia?
Ensure brevity in your answer.  -1. In the year 1998, what is the difference between the CO2 emissions (% of total fuel combustion) in Namibia and CO2 emissions (% of total fuel combustion) in Serbia?
Make the answer very short. 30.09. In the year 2006, what is the difference between the CO2 emissions (% of total fuel combustion) in Arab World and CO2 emissions (% of total fuel combustion) in Namibia?
Offer a terse response. -28.54. In the year 2006, what is the difference between the CO2 emissions (% of total fuel combustion) of Arab World and CO2 emissions (% of total fuel combustion) of Serbia?
Provide a short and direct response. 1.13. In the year 2006, what is the difference between the CO2 emissions (% of total fuel combustion) in Arab World and CO2 emissions (% of total fuel combustion) in Trinidad and Tobago?
Your answer should be compact. 1.67. In the year 2006, what is the difference between the CO2 emissions (% of total fuel combustion) in Namibia and CO2 emissions (% of total fuel combustion) in Serbia?
Keep it short and to the point. 29.67. In the year 2006, what is the difference between the CO2 emissions (% of total fuel combustion) in Namibia and CO2 emissions (% of total fuel combustion) in Trinidad and Tobago?
Your answer should be very brief. 30.21. In the year 2006, what is the difference between the CO2 emissions (% of total fuel combustion) of Serbia and CO2 emissions (% of total fuel combustion) of Trinidad and Tobago?
Keep it short and to the point. 0.54. In the year 2007, what is the difference between the CO2 emissions (% of total fuel combustion) in Arab World and CO2 emissions (% of total fuel combustion) in Namibia?
Give a very brief answer. -28.73. In the year 2007, what is the difference between the CO2 emissions (% of total fuel combustion) in Arab World and CO2 emissions (% of total fuel combustion) in Serbia?
Offer a terse response. -1.34. In the year 2007, what is the difference between the CO2 emissions (% of total fuel combustion) in Arab World and CO2 emissions (% of total fuel combustion) in Trinidad and Tobago?
Offer a terse response. 1.72. In the year 2007, what is the difference between the CO2 emissions (% of total fuel combustion) in Namibia and CO2 emissions (% of total fuel combustion) in Serbia?
Make the answer very short. 27.39. In the year 2007, what is the difference between the CO2 emissions (% of total fuel combustion) of Namibia and CO2 emissions (% of total fuel combustion) of Trinidad and Tobago?
Provide a short and direct response. 30.45. In the year 2007, what is the difference between the CO2 emissions (% of total fuel combustion) in Serbia and CO2 emissions (% of total fuel combustion) in Trinidad and Tobago?
Provide a succinct answer. 3.06. What is the ratio of the CO2 emissions (% of total fuel combustion) in Arab World in 1992 to that in 1993?
Keep it short and to the point. 1.16. What is the ratio of the CO2 emissions (% of total fuel combustion) of Namibia in 1992 to that in 1993?
Offer a very short reply. 1.18. What is the ratio of the CO2 emissions (% of total fuel combustion) in Serbia in 1992 to that in 1993?
Offer a terse response. 0.98. What is the ratio of the CO2 emissions (% of total fuel combustion) in Trinidad and Tobago in 1992 to that in 1993?
Make the answer very short. 0.97. What is the ratio of the CO2 emissions (% of total fuel combustion) of Arab World in 1992 to that in 1994?
Your answer should be compact. 1.37. What is the ratio of the CO2 emissions (% of total fuel combustion) of Namibia in 1992 to that in 1994?
Provide a short and direct response. 1.09. What is the ratio of the CO2 emissions (% of total fuel combustion) of Serbia in 1992 to that in 1994?
Give a very brief answer. 1.04. What is the ratio of the CO2 emissions (% of total fuel combustion) in Arab World in 1992 to that in 1995?
Make the answer very short. 1.17. What is the ratio of the CO2 emissions (% of total fuel combustion) of Namibia in 1992 to that in 1995?
Offer a terse response. 0.89. What is the ratio of the CO2 emissions (% of total fuel combustion) of Serbia in 1992 to that in 1995?
Your answer should be compact. 1.82. What is the ratio of the CO2 emissions (% of total fuel combustion) in Arab World in 1992 to that in 1996?
Offer a terse response. 1.28. What is the ratio of the CO2 emissions (% of total fuel combustion) in Namibia in 1992 to that in 1996?
Your answer should be very brief. 1.73. What is the ratio of the CO2 emissions (% of total fuel combustion) of Serbia in 1992 to that in 1996?
Give a very brief answer. 1.08. What is the ratio of the CO2 emissions (% of total fuel combustion) in Arab World in 1992 to that in 1998?
Your answer should be very brief. 1.21. What is the ratio of the CO2 emissions (% of total fuel combustion) in Namibia in 1992 to that in 1998?
Offer a terse response. 1.7. What is the ratio of the CO2 emissions (% of total fuel combustion) of Serbia in 1992 to that in 1998?
Make the answer very short. 1.31. What is the ratio of the CO2 emissions (% of total fuel combustion) in Arab World in 1992 to that in 2006?
Make the answer very short. 0.91. What is the ratio of the CO2 emissions (% of total fuel combustion) of Namibia in 1992 to that in 2006?
Provide a short and direct response. 1.82. What is the ratio of the CO2 emissions (% of total fuel combustion) in Serbia in 1992 to that in 2006?
Your response must be concise. 5.43. What is the ratio of the CO2 emissions (% of total fuel combustion) of Trinidad and Tobago in 1992 to that in 2006?
Provide a succinct answer. 6.61e+15. What is the ratio of the CO2 emissions (% of total fuel combustion) in Arab World in 1992 to that in 2007?
Provide a short and direct response. 0.88. What is the ratio of the CO2 emissions (% of total fuel combustion) of Namibia in 1992 to that in 2007?
Provide a short and direct response. 1.8. What is the ratio of the CO2 emissions (% of total fuel combustion) of Serbia in 1992 to that in 2007?
Your answer should be very brief. 0.96. What is the ratio of the CO2 emissions (% of total fuel combustion) of Trinidad and Tobago in 1992 to that in 2007?
Ensure brevity in your answer.  7.03e+15. What is the ratio of the CO2 emissions (% of total fuel combustion) in Arab World in 1993 to that in 1994?
Offer a terse response. 1.18. What is the ratio of the CO2 emissions (% of total fuel combustion) in Namibia in 1993 to that in 1994?
Provide a succinct answer. 0.92. What is the ratio of the CO2 emissions (% of total fuel combustion) of Serbia in 1993 to that in 1994?
Offer a very short reply. 1.06. What is the ratio of the CO2 emissions (% of total fuel combustion) of Namibia in 1993 to that in 1995?
Your answer should be compact. 0.75. What is the ratio of the CO2 emissions (% of total fuel combustion) in Serbia in 1993 to that in 1995?
Give a very brief answer. 1.86. What is the ratio of the CO2 emissions (% of total fuel combustion) in Arab World in 1993 to that in 1996?
Your answer should be compact. 1.1. What is the ratio of the CO2 emissions (% of total fuel combustion) in Namibia in 1993 to that in 1996?
Your response must be concise. 1.46. What is the ratio of the CO2 emissions (% of total fuel combustion) of Serbia in 1993 to that in 1996?
Provide a short and direct response. 1.1. What is the ratio of the CO2 emissions (% of total fuel combustion) of Arab World in 1993 to that in 1998?
Make the answer very short. 1.04. What is the ratio of the CO2 emissions (% of total fuel combustion) of Namibia in 1993 to that in 1998?
Keep it short and to the point. 1.44. What is the ratio of the CO2 emissions (% of total fuel combustion) of Serbia in 1993 to that in 1998?
Offer a terse response. 1.34. What is the ratio of the CO2 emissions (% of total fuel combustion) of Arab World in 1993 to that in 2006?
Your response must be concise. 0.78. What is the ratio of the CO2 emissions (% of total fuel combustion) of Namibia in 1993 to that in 2006?
Provide a short and direct response. 1.54. What is the ratio of the CO2 emissions (% of total fuel combustion) of Serbia in 1993 to that in 2006?
Offer a very short reply. 5.55. What is the ratio of the CO2 emissions (% of total fuel combustion) of Trinidad and Tobago in 1993 to that in 2006?
Your answer should be very brief. 6.84e+15. What is the ratio of the CO2 emissions (% of total fuel combustion) of Arab World in 1993 to that in 2007?
Give a very brief answer. 0.76. What is the ratio of the CO2 emissions (% of total fuel combustion) of Namibia in 1993 to that in 2007?
Offer a very short reply. 1.53. What is the ratio of the CO2 emissions (% of total fuel combustion) in Serbia in 1993 to that in 2007?
Ensure brevity in your answer.  0.98. What is the ratio of the CO2 emissions (% of total fuel combustion) in Trinidad and Tobago in 1993 to that in 2007?
Provide a short and direct response. 7.28e+15. What is the ratio of the CO2 emissions (% of total fuel combustion) in Arab World in 1994 to that in 1995?
Provide a succinct answer. 0.85. What is the ratio of the CO2 emissions (% of total fuel combustion) in Namibia in 1994 to that in 1995?
Offer a very short reply. 0.82. What is the ratio of the CO2 emissions (% of total fuel combustion) in Serbia in 1994 to that in 1995?
Your answer should be compact. 1.76. What is the ratio of the CO2 emissions (% of total fuel combustion) of Arab World in 1994 to that in 1996?
Make the answer very short. 0.94. What is the ratio of the CO2 emissions (% of total fuel combustion) in Namibia in 1994 to that in 1996?
Your answer should be very brief. 1.58. What is the ratio of the CO2 emissions (% of total fuel combustion) of Serbia in 1994 to that in 1996?
Give a very brief answer. 1.04. What is the ratio of the CO2 emissions (% of total fuel combustion) in Arab World in 1994 to that in 1998?
Keep it short and to the point. 0.89. What is the ratio of the CO2 emissions (% of total fuel combustion) of Namibia in 1994 to that in 1998?
Your answer should be very brief. 1.56. What is the ratio of the CO2 emissions (% of total fuel combustion) of Serbia in 1994 to that in 1998?
Provide a succinct answer. 1.26. What is the ratio of the CO2 emissions (% of total fuel combustion) of Arab World in 1994 to that in 2006?
Your answer should be very brief. 0.66. What is the ratio of the CO2 emissions (% of total fuel combustion) of Namibia in 1994 to that in 2006?
Offer a terse response. 1.67. What is the ratio of the CO2 emissions (% of total fuel combustion) in Serbia in 1994 to that in 2006?
Offer a terse response. 5.23. What is the ratio of the CO2 emissions (% of total fuel combustion) of Arab World in 1994 to that in 2007?
Keep it short and to the point. 0.65. What is the ratio of the CO2 emissions (% of total fuel combustion) of Namibia in 1994 to that in 2007?
Give a very brief answer. 1.65. What is the ratio of the CO2 emissions (% of total fuel combustion) in Serbia in 1994 to that in 2007?
Provide a short and direct response. 0.93. What is the ratio of the CO2 emissions (% of total fuel combustion) in Arab World in 1995 to that in 1996?
Provide a succinct answer. 1.1. What is the ratio of the CO2 emissions (% of total fuel combustion) of Namibia in 1995 to that in 1996?
Provide a succinct answer. 1.94. What is the ratio of the CO2 emissions (% of total fuel combustion) in Serbia in 1995 to that in 1996?
Keep it short and to the point. 0.59. What is the ratio of the CO2 emissions (% of total fuel combustion) of Arab World in 1995 to that in 1998?
Make the answer very short. 1.04. What is the ratio of the CO2 emissions (% of total fuel combustion) of Namibia in 1995 to that in 1998?
Your answer should be very brief. 1.9. What is the ratio of the CO2 emissions (% of total fuel combustion) of Serbia in 1995 to that in 1998?
Your answer should be very brief. 0.72. What is the ratio of the CO2 emissions (% of total fuel combustion) of Arab World in 1995 to that in 2006?
Provide a succinct answer. 0.78. What is the ratio of the CO2 emissions (% of total fuel combustion) of Namibia in 1995 to that in 2006?
Make the answer very short. 2.04. What is the ratio of the CO2 emissions (% of total fuel combustion) of Serbia in 1995 to that in 2006?
Give a very brief answer. 2.97. What is the ratio of the CO2 emissions (% of total fuel combustion) of Arab World in 1995 to that in 2007?
Keep it short and to the point. 0.76. What is the ratio of the CO2 emissions (% of total fuel combustion) of Namibia in 1995 to that in 2007?
Provide a short and direct response. 2.02. What is the ratio of the CO2 emissions (% of total fuel combustion) of Serbia in 1995 to that in 2007?
Keep it short and to the point. 0.53. What is the ratio of the CO2 emissions (% of total fuel combustion) of Arab World in 1996 to that in 1998?
Make the answer very short. 0.95. What is the ratio of the CO2 emissions (% of total fuel combustion) of Namibia in 1996 to that in 1998?
Your response must be concise. 0.98. What is the ratio of the CO2 emissions (% of total fuel combustion) in Serbia in 1996 to that in 1998?
Your response must be concise. 1.22. What is the ratio of the CO2 emissions (% of total fuel combustion) of Arab World in 1996 to that in 2006?
Your answer should be very brief. 0.71. What is the ratio of the CO2 emissions (% of total fuel combustion) in Namibia in 1996 to that in 2006?
Offer a terse response. 1.05. What is the ratio of the CO2 emissions (% of total fuel combustion) in Serbia in 1996 to that in 2006?
Provide a succinct answer. 5.04. What is the ratio of the CO2 emissions (% of total fuel combustion) of Arab World in 1996 to that in 2007?
Offer a terse response. 0.69. What is the ratio of the CO2 emissions (% of total fuel combustion) of Namibia in 1996 to that in 2007?
Make the answer very short. 1.04. What is the ratio of the CO2 emissions (% of total fuel combustion) in Serbia in 1996 to that in 2007?
Offer a terse response. 0.89. What is the ratio of the CO2 emissions (% of total fuel combustion) of Arab World in 1998 to that in 2006?
Offer a terse response. 0.75. What is the ratio of the CO2 emissions (% of total fuel combustion) of Namibia in 1998 to that in 2006?
Offer a terse response. 1.07. What is the ratio of the CO2 emissions (% of total fuel combustion) in Serbia in 1998 to that in 2006?
Give a very brief answer. 4.14. What is the ratio of the CO2 emissions (% of total fuel combustion) of Arab World in 1998 to that in 2007?
Ensure brevity in your answer.  0.73. What is the ratio of the CO2 emissions (% of total fuel combustion) in Namibia in 1998 to that in 2007?
Keep it short and to the point. 1.06. What is the ratio of the CO2 emissions (% of total fuel combustion) of Serbia in 1998 to that in 2007?
Keep it short and to the point. 0.73. What is the ratio of the CO2 emissions (% of total fuel combustion) in Arab World in 2006 to that in 2007?
Provide a succinct answer. 0.97. What is the ratio of the CO2 emissions (% of total fuel combustion) in Namibia in 2006 to that in 2007?
Ensure brevity in your answer.  0.99. What is the ratio of the CO2 emissions (% of total fuel combustion) of Serbia in 2006 to that in 2007?
Your response must be concise. 0.18. What is the ratio of the CO2 emissions (% of total fuel combustion) in Trinidad and Tobago in 2006 to that in 2007?
Your answer should be compact. 1.06. What is the difference between the highest and the second highest CO2 emissions (% of total fuel combustion) of Arab World?
Your answer should be compact. 0.05. What is the difference between the highest and the second highest CO2 emissions (% of total fuel combustion) in Namibia?
Give a very brief answer. 6.66. What is the difference between the highest and the second highest CO2 emissions (% of total fuel combustion) in Serbia?
Your response must be concise. 0.05. What is the difference between the highest and the second highest CO2 emissions (% of total fuel combustion) in Trinidad and Tobago?
Your answer should be very brief. 0.01. What is the difference between the highest and the lowest CO2 emissions (% of total fuel combustion) of Arab World?
Your answer should be compact. 0.61. What is the difference between the highest and the lowest CO2 emissions (% of total fuel combustion) of Namibia?
Give a very brief answer. 31.37. What is the difference between the highest and the lowest CO2 emissions (% of total fuel combustion) in Serbia?
Provide a succinct answer. 2.52. What is the difference between the highest and the lowest CO2 emissions (% of total fuel combustion) in Trinidad and Tobago?
Give a very brief answer. 0.35. 